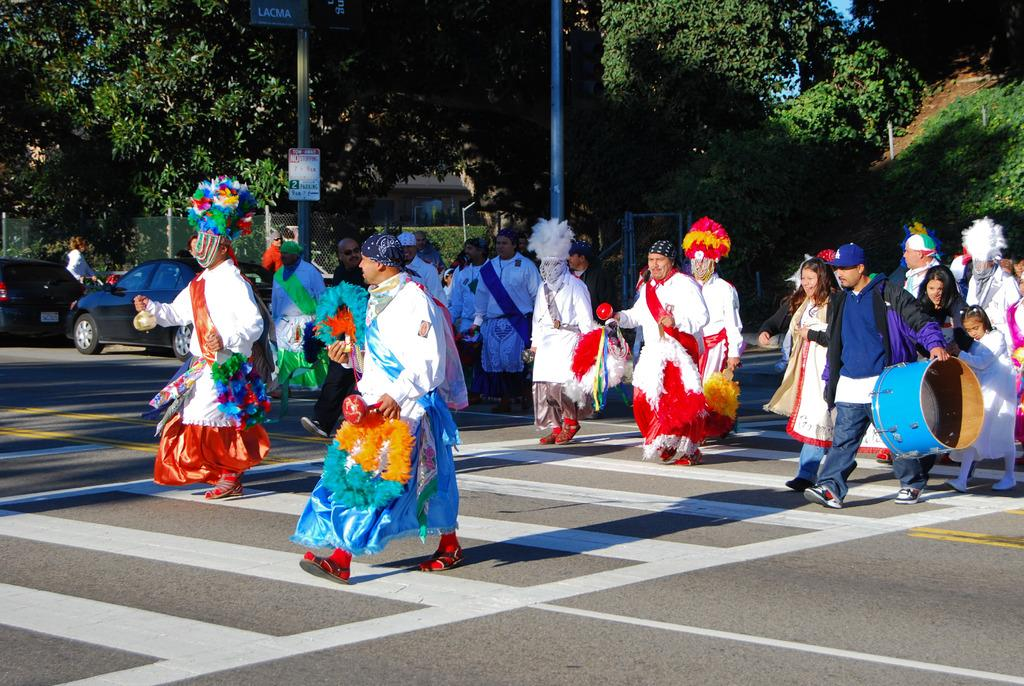What is happening with the group of people in the image? The people are walking on the road in the image. What are the people wearing? The people are wearing different costumes in the image. What is behind the group of people? There are two cars behind the group of people in the image. What can be seen around the road in the image? There are many trees around the road in the image. What type of cheese is being handed out to the people in the image? There is no cheese present in the image; the people are wearing costumes and walking on the road. 